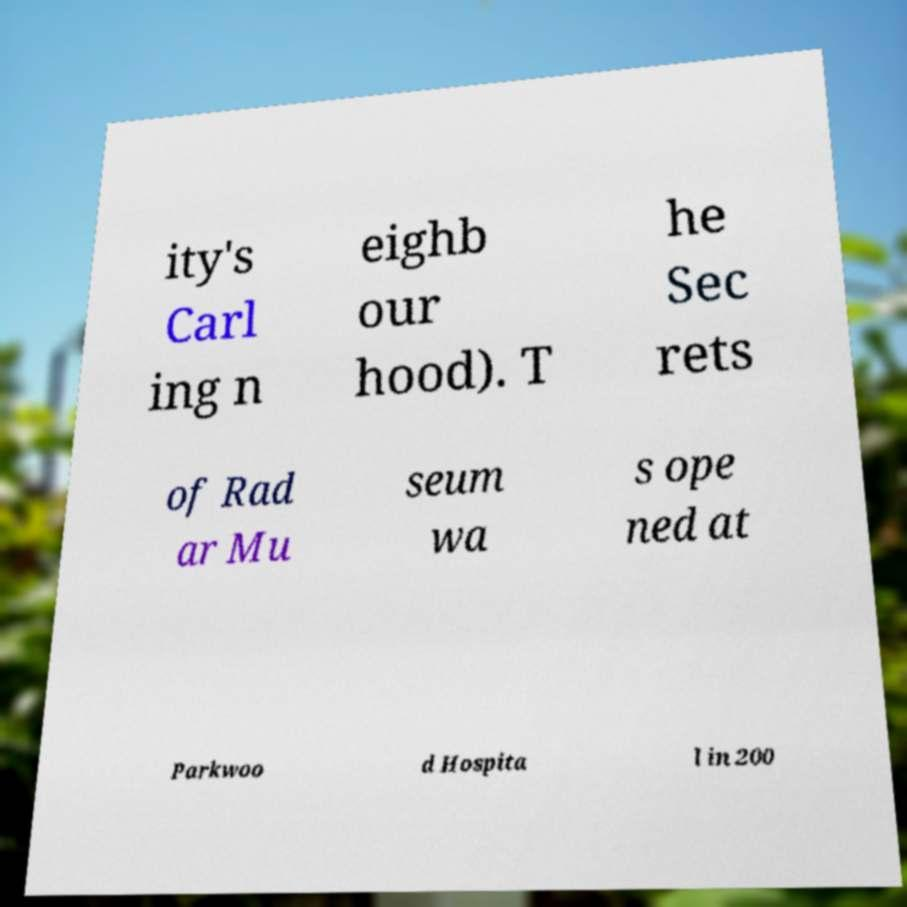Please read and relay the text visible in this image. What does it say? ity's Carl ing n eighb our hood). T he Sec rets of Rad ar Mu seum wa s ope ned at Parkwoo d Hospita l in 200 